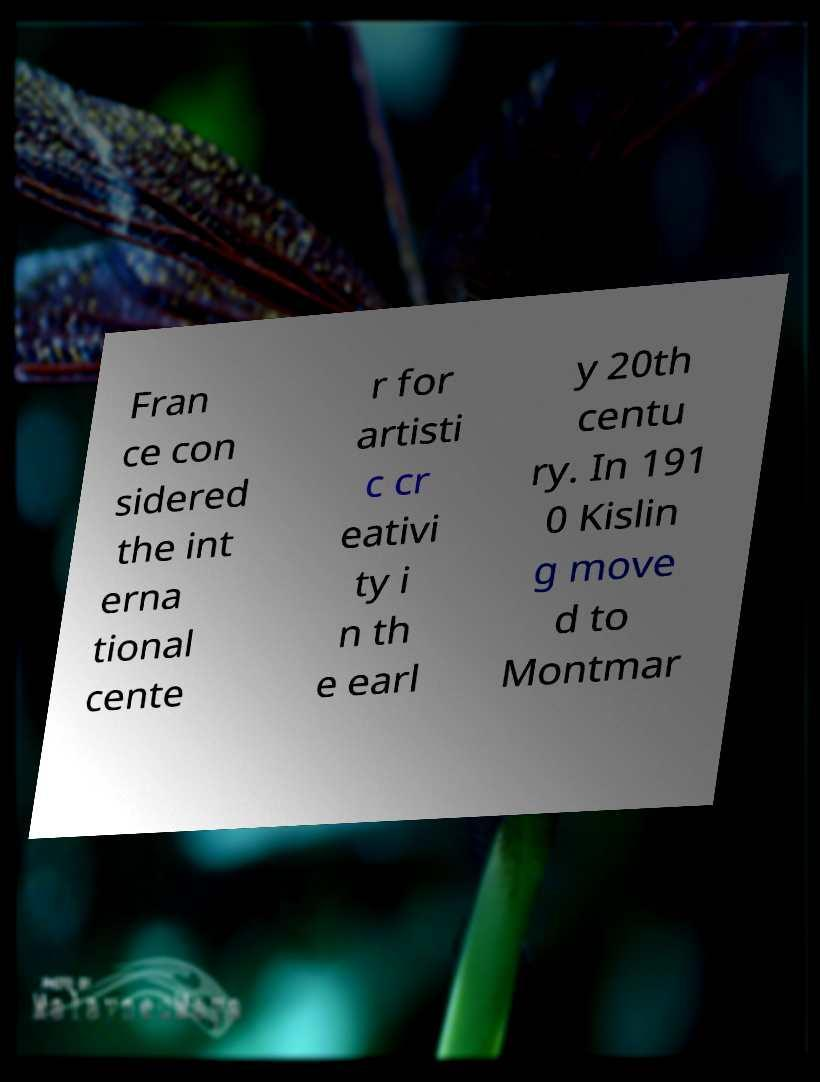Please identify and transcribe the text found in this image. Fran ce con sidered the int erna tional cente r for artisti c cr eativi ty i n th e earl y 20th centu ry. In 191 0 Kislin g move d to Montmar 